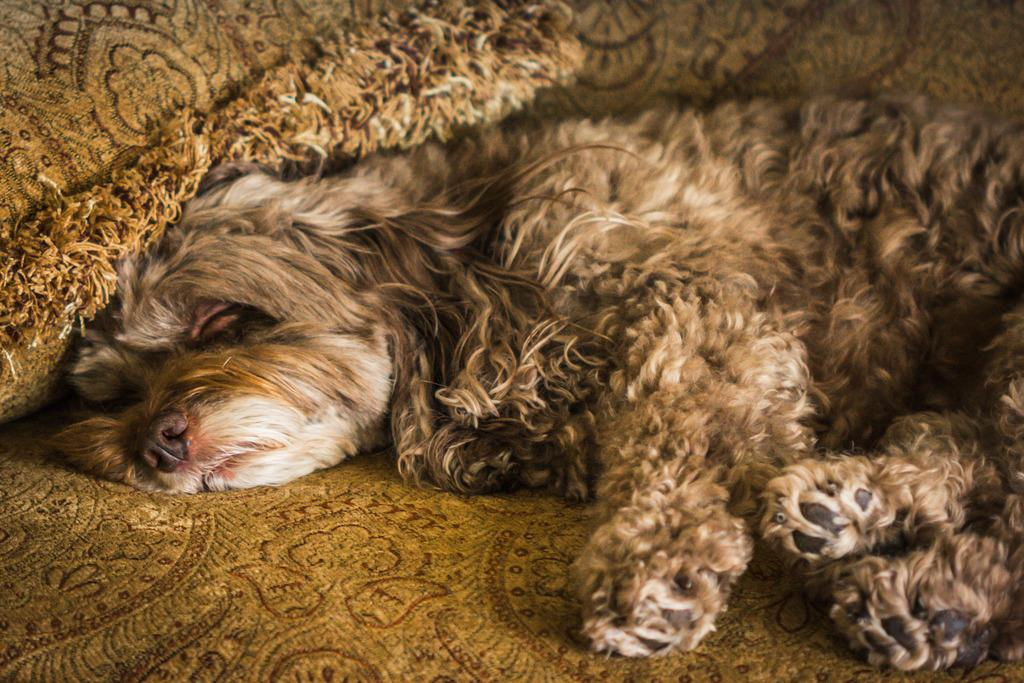What type of animal is in the image? There is a dog in the image. What is the dog doing in the image? The dog is sleeping. What surface is the dog resting on? The dog is on a carpet. How many cows are present in the image? There are no cows present in the image; it features a dog sleeping on a carpet. What is the dog saying as it waves good-bye in the image? The dog is not saying anything or waving good-bye in the image, as it is sleeping. 